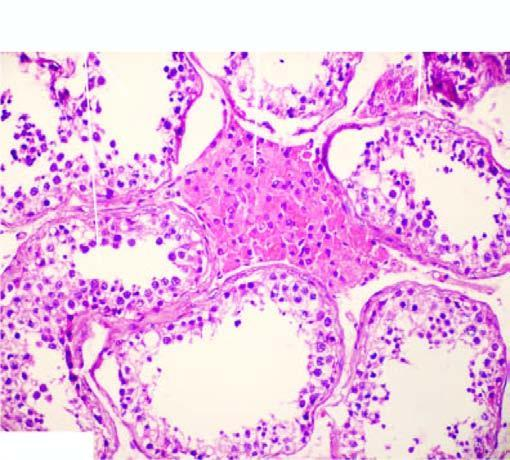s the interstitial vasculature prominence of leydig cells in the interstitium?
Answer the question using a single word or phrase. Yes 